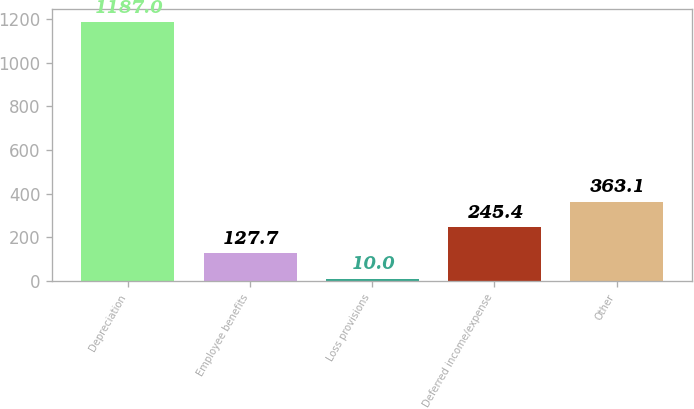Convert chart. <chart><loc_0><loc_0><loc_500><loc_500><bar_chart><fcel>Depreciation<fcel>Employee benefits<fcel>Loss provisions<fcel>Deferred income/expense<fcel>Other<nl><fcel>1187<fcel>127.7<fcel>10<fcel>245.4<fcel>363.1<nl></chart> 